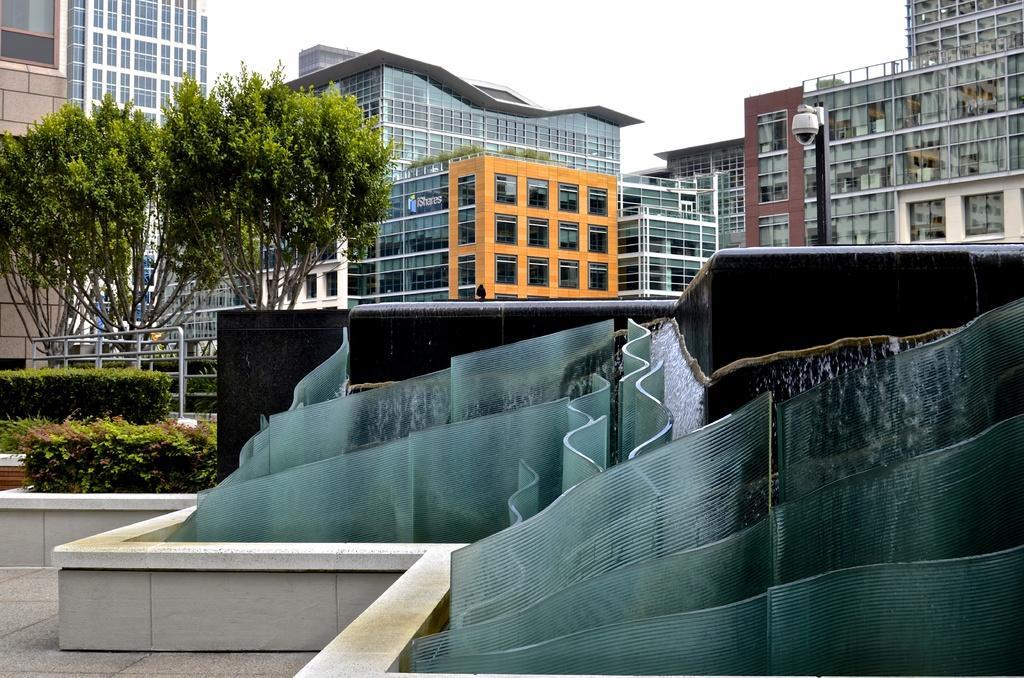How would you summarize this image in a sentence or two? In this image at the bottom we can see designs made with glasses. In the background there are trees, fences, plants, security camera on a pole, buildings, poles, glass doors and sky. 